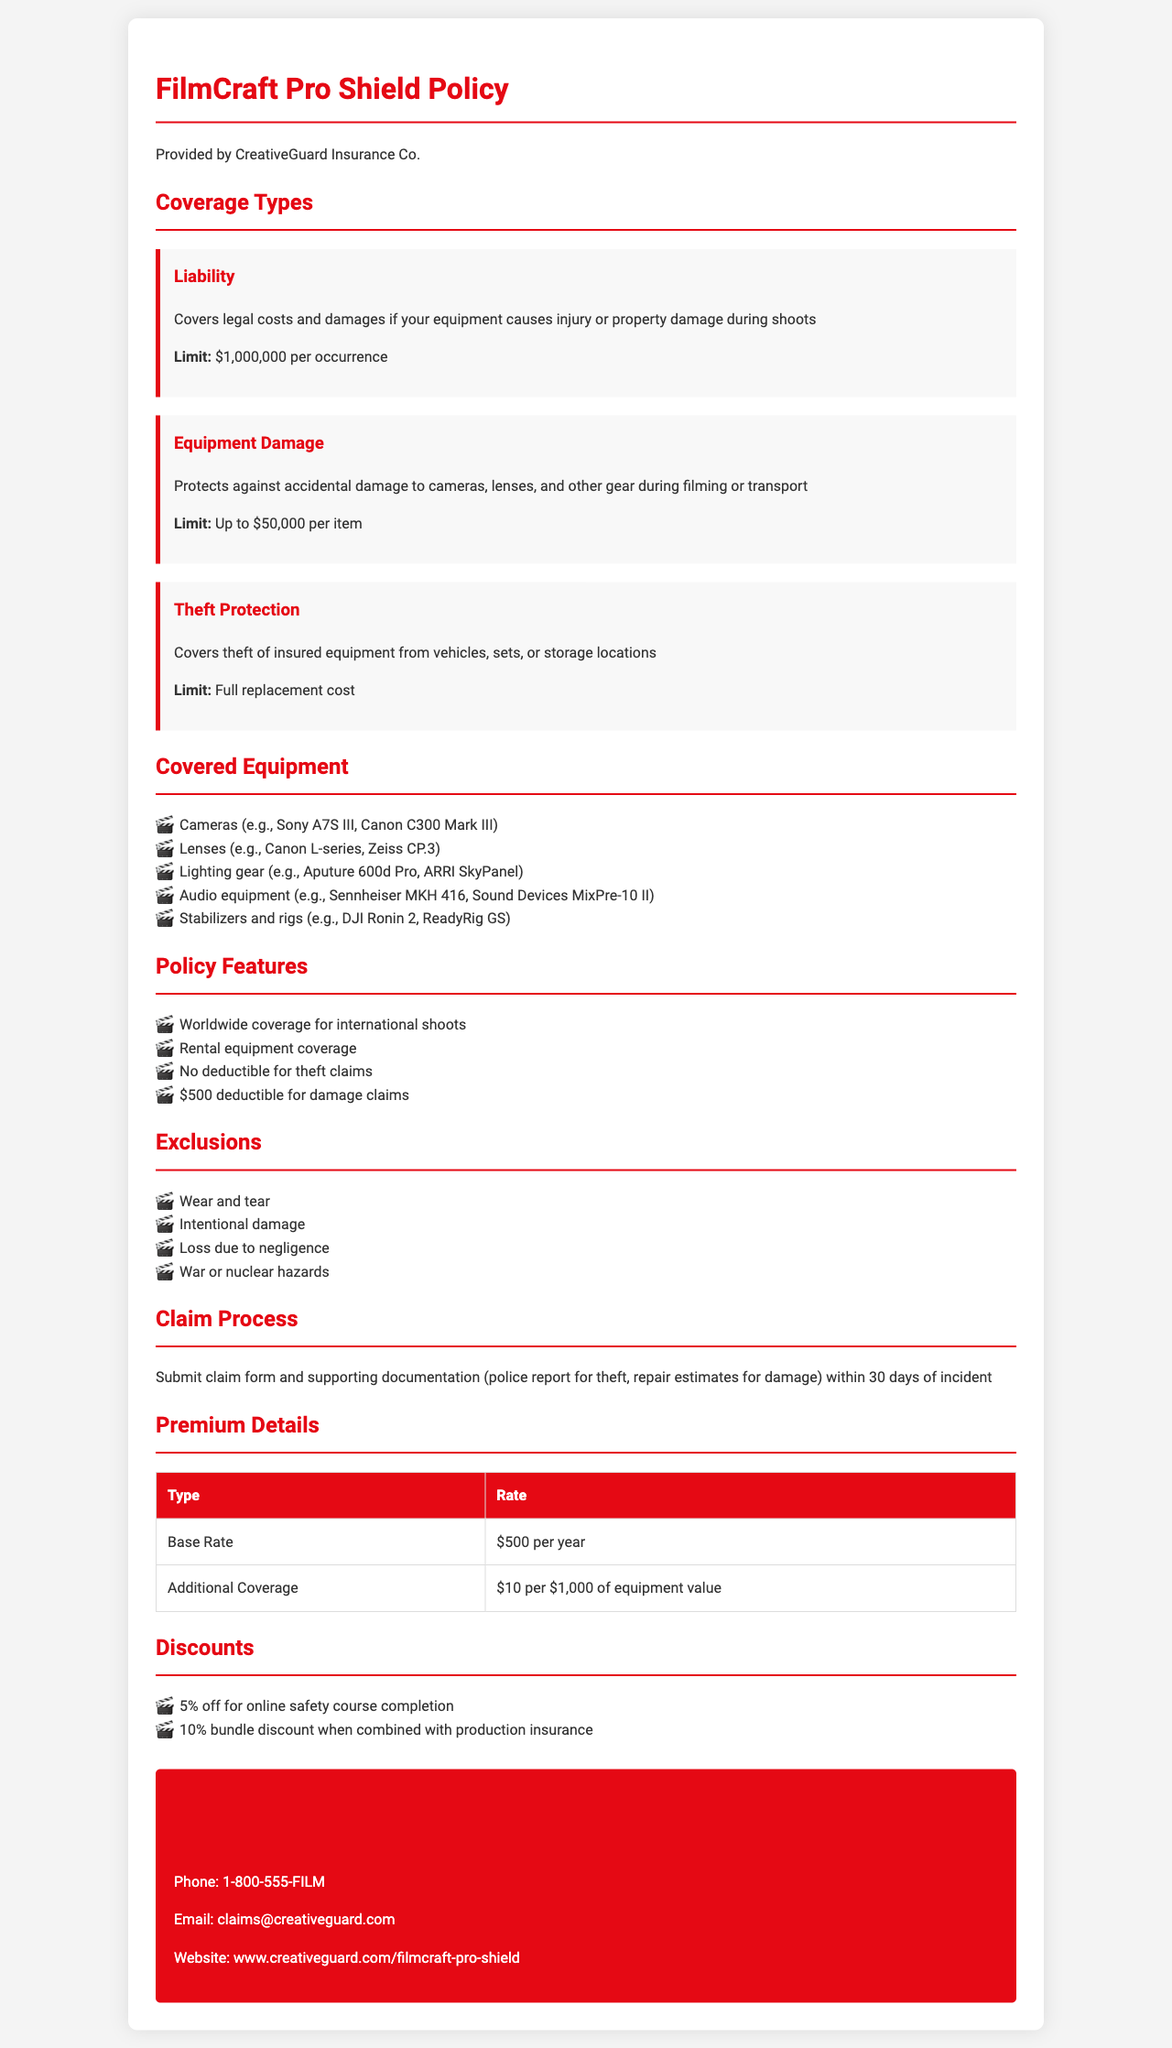what is the limit for liability coverage? The limit for liability coverage is stated in the document under Coverage Types.
Answer: $1,000,000 per occurrence what type of equipment is covered related to theft protection? The document specifies theft protection for insured equipment in the Theft Protection section.
Answer: Insured equipment what is the deductible for damage claims? The document details the deductible amount under Policy Features in terms of damage claims.
Answer: $500 how long do you have to submit a claim after an incident? The claim process section indicates the timeframe to submit a claim.
Answer: 30 days what discount do you get for completing an online safety course? The Discounts section lists the discounts available, including one for completing an online safety course.
Answer: 5% off what is the base rate for the insurance policy? The Premium Details section specifies the base rate for the insurance policy.
Answer: $500 per year which company provides the FilmCraft Pro Shield Policy? The introductory section names the company responsible for this policy.
Answer: CreativeGuard Insurance Co what type of damage is excluded from coverage? The Exclusions section specifies damages that are not covered by this policy.
Answer: Wear and tear how much is the additional coverage rate per $1,000 of equipment value? The Premium Details section includes the rate for additional coverage.
Answer: $10 per $1,000 